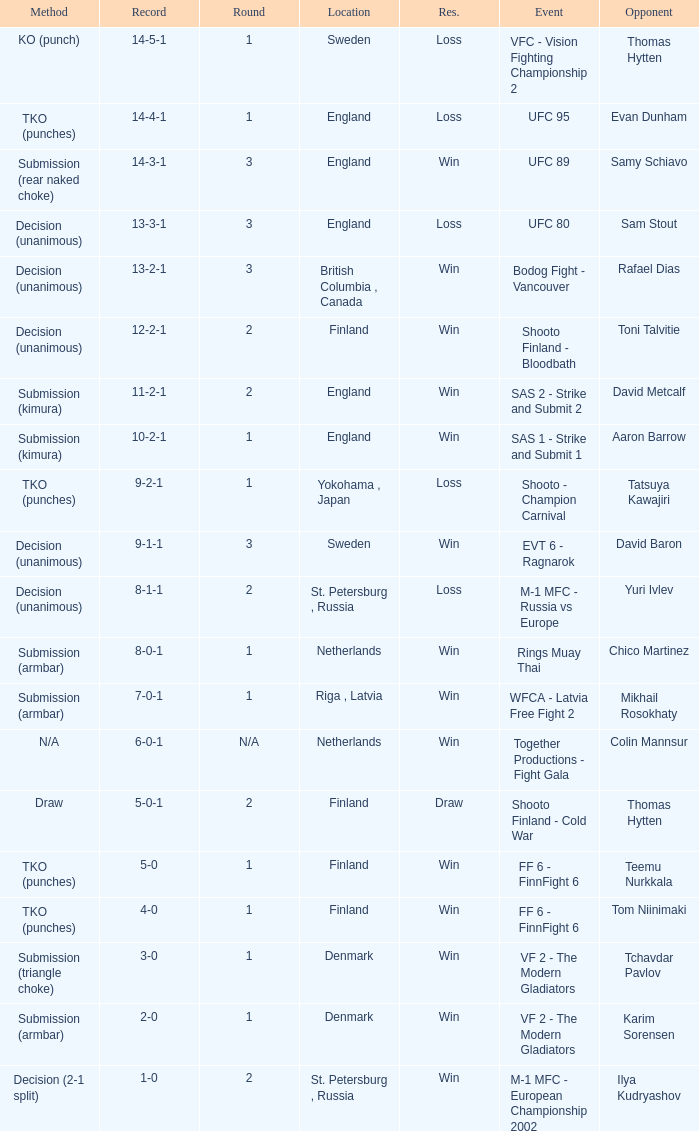What is the round in Finland with a draw for method? 2.0. Would you mind parsing the complete table? {'header': ['Method', 'Record', 'Round', 'Location', 'Res.', 'Event', 'Opponent'], 'rows': [['KO (punch)', '14-5-1', '1', 'Sweden', 'Loss', 'VFC - Vision Fighting Championship 2', 'Thomas Hytten'], ['TKO (punches)', '14-4-1', '1', 'England', 'Loss', 'UFC 95', 'Evan Dunham'], ['Submission (rear naked choke)', '14-3-1', '3', 'England', 'Win', 'UFC 89', 'Samy Schiavo'], ['Decision (unanimous)', '13-3-1', '3', 'England', 'Loss', 'UFC 80', 'Sam Stout'], ['Decision (unanimous)', '13-2-1', '3', 'British Columbia , Canada', 'Win', 'Bodog Fight - Vancouver', 'Rafael Dias'], ['Decision (unanimous)', '12-2-1', '2', 'Finland', 'Win', 'Shooto Finland - Bloodbath', 'Toni Talvitie'], ['Submission (kimura)', '11-2-1', '2', 'England', 'Win', 'SAS 2 - Strike and Submit 2', 'David Metcalf'], ['Submission (kimura)', '10-2-1', '1', 'England', 'Win', 'SAS 1 - Strike and Submit 1', 'Aaron Barrow'], ['TKO (punches)', '9-2-1', '1', 'Yokohama , Japan', 'Loss', 'Shooto - Champion Carnival', 'Tatsuya Kawajiri'], ['Decision (unanimous)', '9-1-1', '3', 'Sweden', 'Win', 'EVT 6 - Ragnarok', 'David Baron'], ['Decision (unanimous)', '8-1-1', '2', 'St. Petersburg , Russia', 'Loss', 'M-1 MFC - Russia vs Europe', 'Yuri Ivlev'], ['Submission (armbar)', '8-0-1', '1', 'Netherlands', 'Win', 'Rings Muay Thai', 'Chico Martinez'], ['Submission (armbar)', '7-0-1', '1', 'Riga , Latvia', 'Win', 'WFCA - Latvia Free Fight 2', 'Mikhail Rosokhaty'], ['N/A', '6-0-1', 'N/A', 'Netherlands', 'Win', 'Together Productions - Fight Gala', 'Colin Mannsur'], ['Draw', '5-0-1', '2', 'Finland', 'Draw', 'Shooto Finland - Cold War', 'Thomas Hytten'], ['TKO (punches)', '5-0', '1', 'Finland', 'Win', 'FF 6 - FinnFight 6', 'Teemu Nurkkala'], ['TKO (punches)', '4-0', '1', 'Finland', 'Win', 'FF 6 - FinnFight 6', 'Tom Niinimaki'], ['Submission (triangle choke)', '3-0', '1', 'Denmark', 'Win', 'VF 2 - The Modern Gladiators', 'Tchavdar Pavlov'], ['Submission (armbar)', '2-0', '1', 'Denmark', 'Win', 'VF 2 - The Modern Gladiators', 'Karim Sorensen'], ['Decision (2-1 split)', '1-0', '2', 'St. Petersburg , Russia', 'Win', 'M-1 MFC - European Championship 2002', 'Ilya Kudryashov']]} 